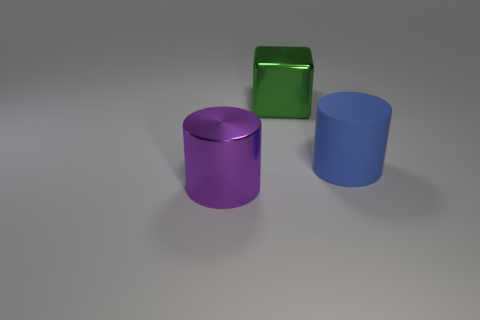Subtract all gray blocks. Subtract all gray cylinders. How many blocks are left? 1 Add 3 large yellow matte cubes. How many objects exist? 6 Subtract all cubes. How many objects are left? 2 Subtract all big purple objects. Subtract all big green things. How many objects are left? 1 Add 1 big green metal objects. How many big green metal objects are left? 2 Add 1 green things. How many green things exist? 2 Subtract 0 brown cylinders. How many objects are left? 3 